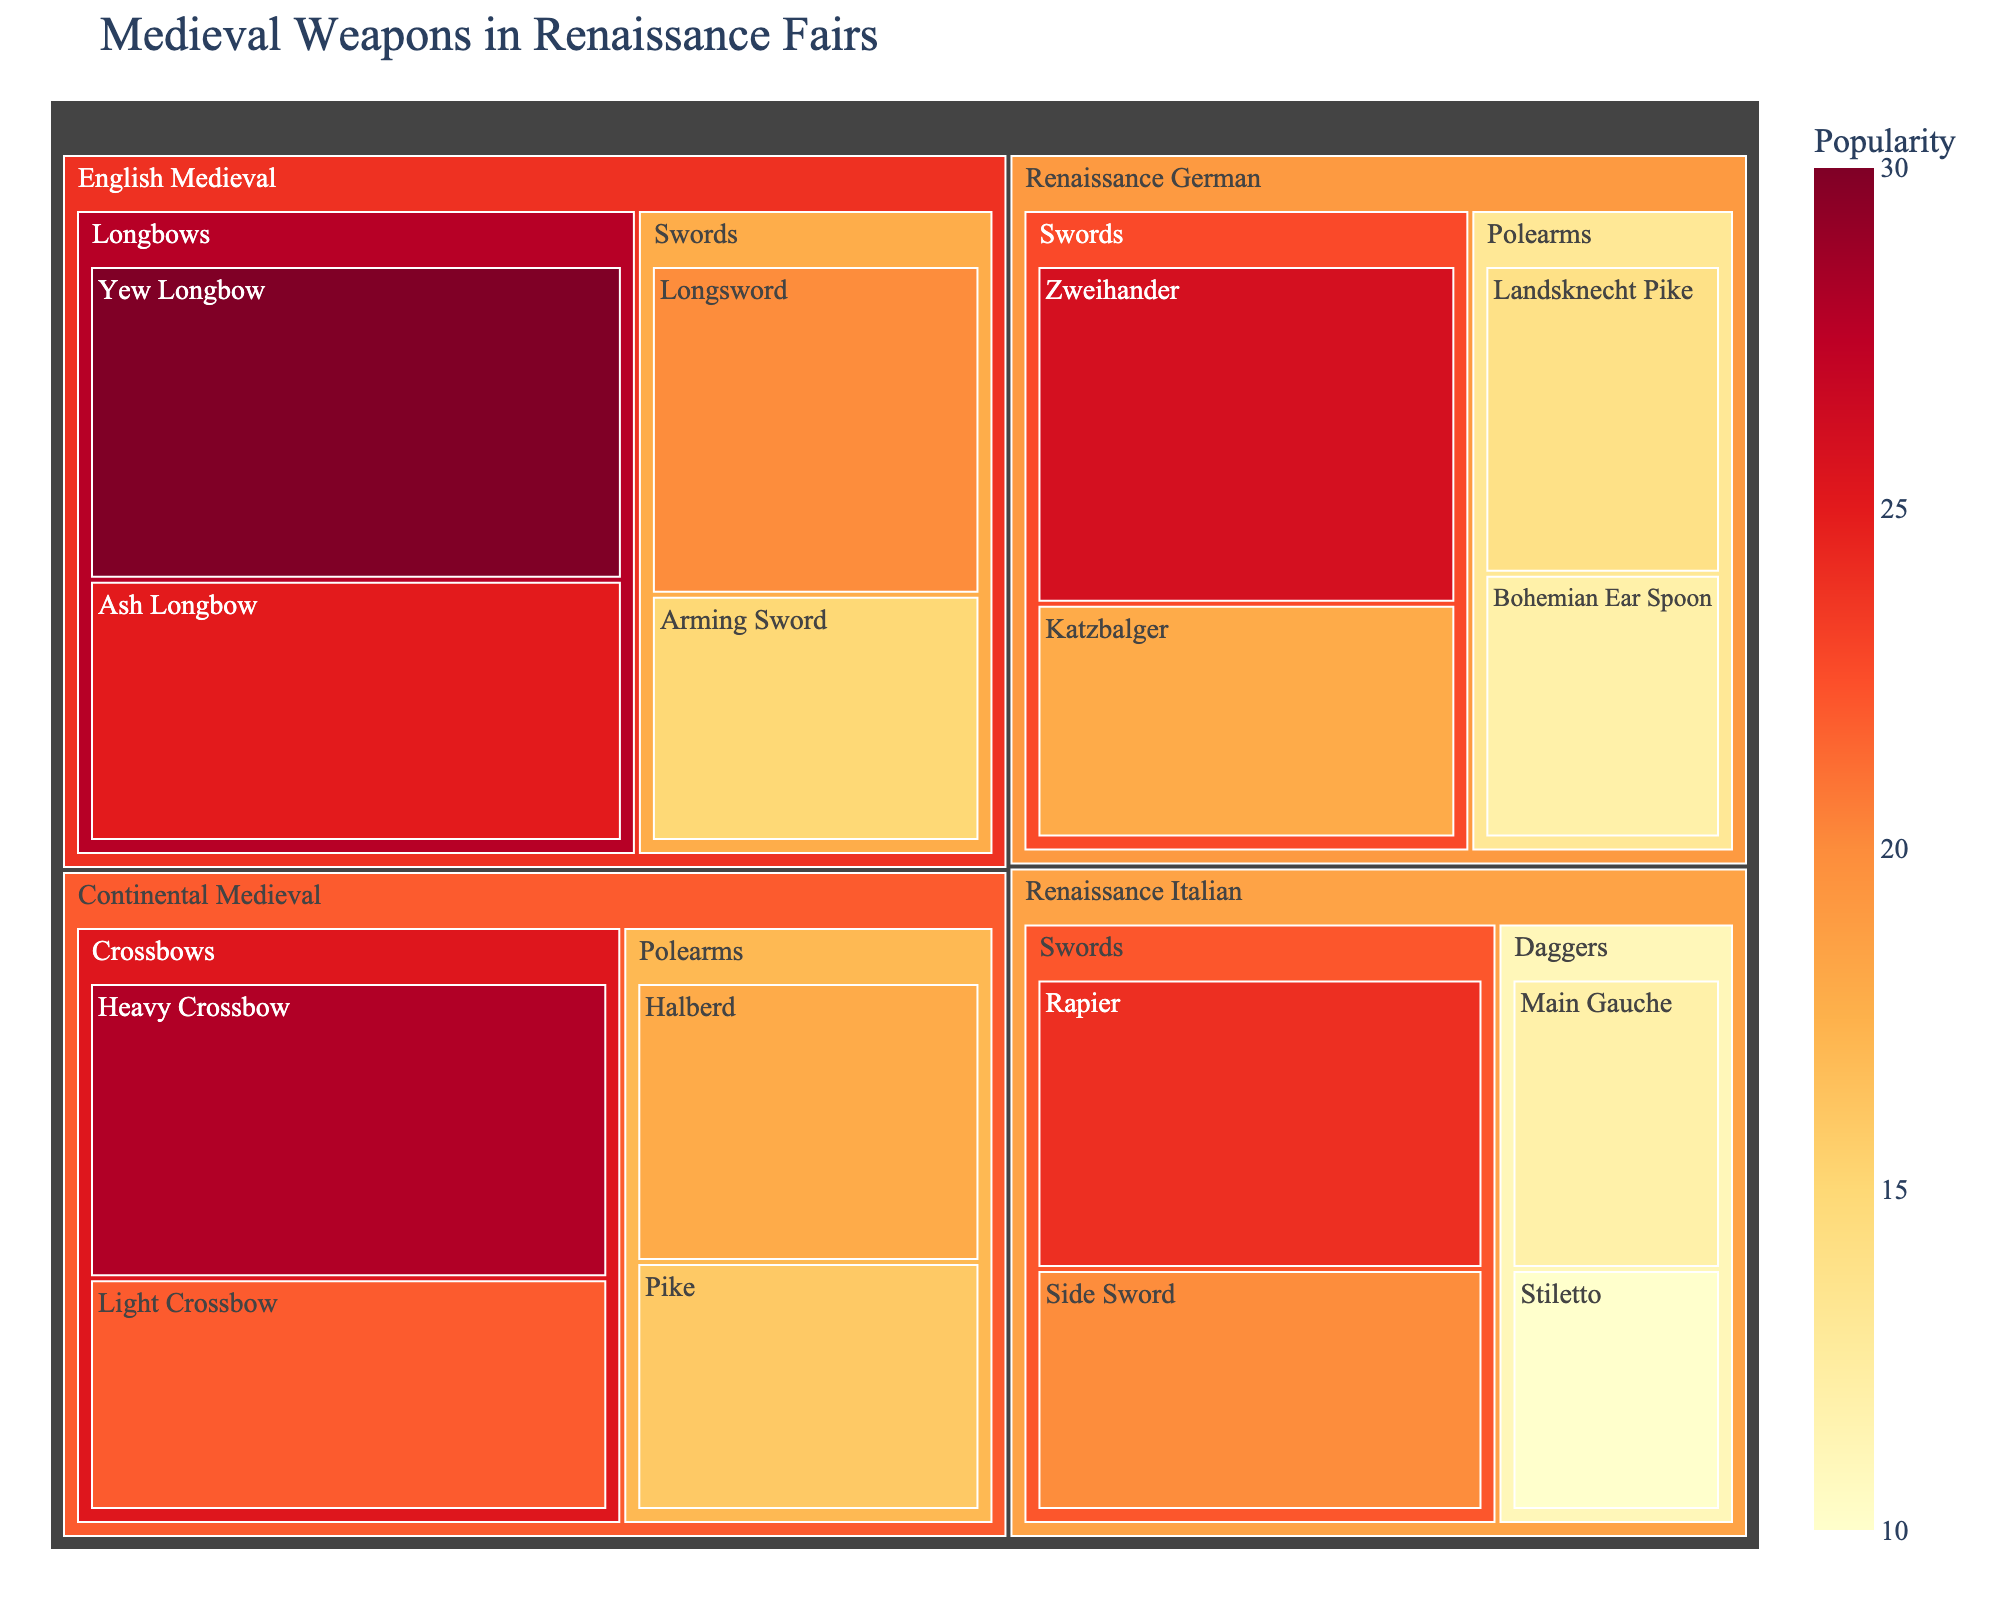What is the most popular medieval weapon in the English Medieval category? The most popular weapon in the English Medieval category is identified by the largest value under any of its subcategories. From the figure, the Yew Longbow has the highest value of 30.
Answer: Yew Longbow What is the total popularity of all weapons in the Renaissance German category? To find this, sum up the values of all weapons under the Renaissance German category. The weapons are Zweihander (26), Katzbalger (18), Landsknecht Pike (14), and Bohemian Ear Spoon (12). So, 26 + 18 + 14 + 12 = 70.
Answer: 70 Which category has a higher combined popularity: Crossbows in Continental Medieval or Swords in Renaissance Italian? First, sum the values for Crossbows in Continental Medieval: Heavy Crossbow (28) + Light Crossbow (22) = 50. Then, sum the values for Swords in Renaissance Italian: Rapier (24) + Side Sword (20) = 44. Compare the two sums: 50 is greater than 44.
Answer: Crossbows in Continental Medieval How many different subcategories are there in the figure? Count the visible subcategories across all categories. The subcategories are Longbows, Swords, Crossbows, Polearms, Swords (again), Daggers, Swords (again), and Polearms (again). Note that “Swords” and “Polearms” appear more than once but are distinct within each category. There are 8 distinct subcategories.
Answer: 8 What is the least popular weapon in the Renaissance Italian category? Looking at the values for weapons in the Renaissance Italian category, the weapon with the smallest value is the Stiletto with 10.
Answer: Stiletto Which category has the highest average weapon popularity? Calculate the average popularity for each category: 
- English Medieval: (30 + 25 + 20 + 15) / 4 = 22.5
- Continental Medieval: (28 + 22 + 18 + 16) / 4 = 21
- Renaissance Italian: (24 + 20 + 12 + 10) / 4 = 16.5
- Renaissance German: (26 + 18 + 14 + 12) / 4 = 17.5
English Medieval has the highest average.
Answer: English Medieval Which subcategory in Continental Medieval has the higher total popularity, Crossbows or Polearms? Sum the values for each subcategory in Continental Medieval: Crossbows: 28 + 22 = 50, Polearms: 18 + 16 = 34. Crossbows have the higher total popularity.
Answer: Crossbows Is the Yew Longbow more popular than the Zweihander? Compare the value of the Yew Longbow (30) with the value of the Zweihander (26). Since 30 is greater than 26, Yew Longbow is more popular.
Answer: Yes How does the popularity of the Halberd compare to that of the Main Gauche? The popularity of Halberd is 18, while the Main Gauche has a popularity of 12. Since 18 is greater than 12, Halberd is more popular than Main Gauche.
Answer: Halberd is more popular 